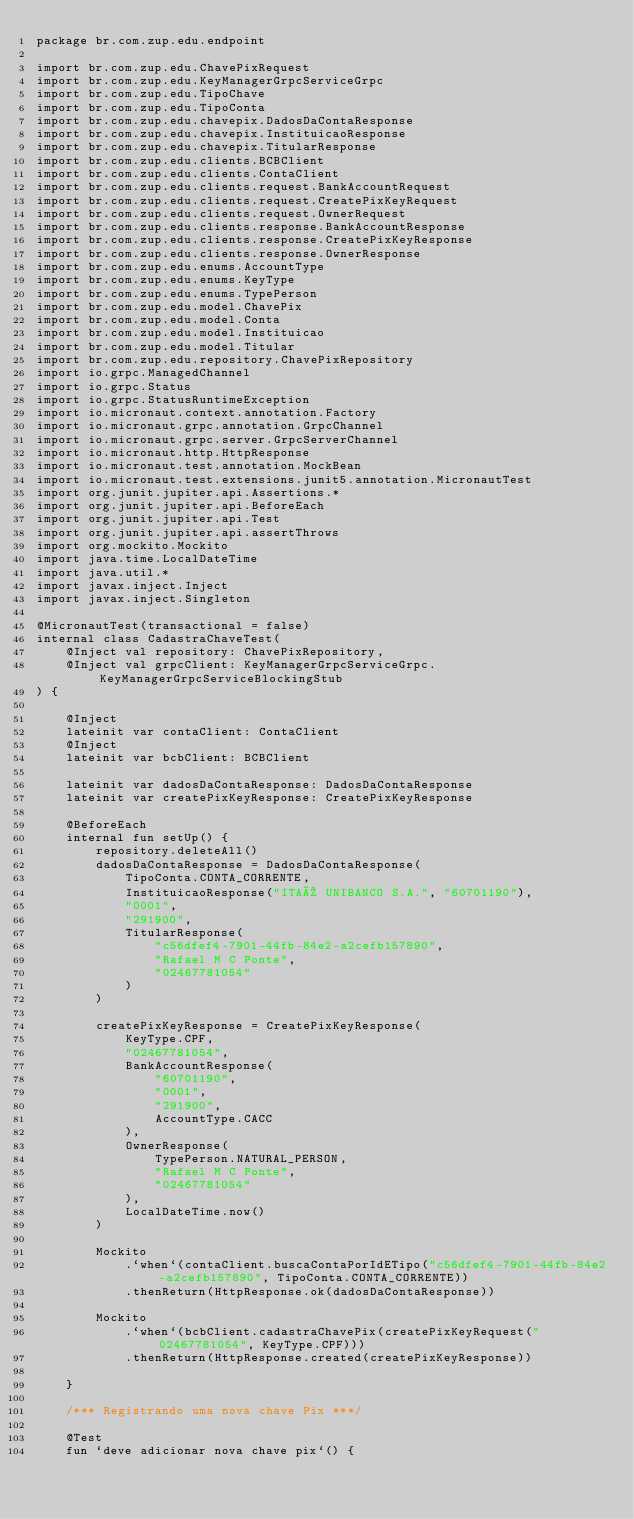Convert code to text. <code><loc_0><loc_0><loc_500><loc_500><_Kotlin_>package br.com.zup.edu.endpoint

import br.com.zup.edu.ChavePixRequest
import br.com.zup.edu.KeyManagerGrpcServiceGrpc
import br.com.zup.edu.TipoChave
import br.com.zup.edu.TipoConta
import br.com.zup.edu.chavepix.DadosDaContaResponse
import br.com.zup.edu.chavepix.InstituicaoResponse
import br.com.zup.edu.chavepix.TitularResponse
import br.com.zup.edu.clients.BCBClient
import br.com.zup.edu.clients.ContaClient
import br.com.zup.edu.clients.request.BankAccountRequest
import br.com.zup.edu.clients.request.CreatePixKeyRequest
import br.com.zup.edu.clients.request.OwnerRequest
import br.com.zup.edu.clients.response.BankAccountResponse
import br.com.zup.edu.clients.response.CreatePixKeyResponse
import br.com.zup.edu.clients.response.OwnerResponse
import br.com.zup.edu.enums.AccountType
import br.com.zup.edu.enums.KeyType
import br.com.zup.edu.enums.TypePerson
import br.com.zup.edu.model.ChavePix
import br.com.zup.edu.model.Conta
import br.com.zup.edu.model.Instituicao
import br.com.zup.edu.model.Titular
import br.com.zup.edu.repository.ChavePixRepository
import io.grpc.ManagedChannel
import io.grpc.Status
import io.grpc.StatusRuntimeException
import io.micronaut.context.annotation.Factory
import io.micronaut.grpc.annotation.GrpcChannel
import io.micronaut.grpc.server.GrpcServerChannel
import io.micronaut.http.HttpResponse
import io.micronaut.test.annotation.MockBean
import io.micronaut.test.extensions.junit5.annotation.MicronautTest
import org.junit.jupiter.api.Assertions.*
import org.junit.jupiter.api.BeforeEach
import org.junit.jupiter.api.Test
import org.junit.jupiter.api.assertThrows
import org.mockito.Mockito
import java.time.LocalDateTime
import java.util.*
import javax.inject.Inject
import javax.inject.Singleton

@MicronautTest(transactional = false)
internal class CadastraChaveTest(
    @Inject val repository: ChavePixRepository,
    @Inject val grpcClient: KeyManagerGrpcServiceGrpc.KeyManagerGrpcServiceBlockingStub
) {

    @Inject
    lateinit var contaClient: ContaClient
    @Inject
    lateinit var bcbClient: BCBClient

    lateinit var dadosDaContaResponse: DadosDaContaResponse
    lateinit var createPixKeyResponse: CreatePixKeyResponse

    @BeforeEach
    internal fun setUp() {
        repository.deleteAll()
        dadosDaContaResponse = DadosDaContaResponse(
            TipoConta.CONTA_CORRENTE,
            InstituicaoResponse("ITAÚ UNIBANCO S.A.", "60701190"),
            "0001",
            "291900",
            TitularResponse(
                "c56dfef4-7901-44fb-84e2-a2cefb157890",
                "Rafael M C Ponte",
                "02467781054"
            )
        )

        createPixKeyResponse = CreatePixKeyResponse(
            KeyType.CPF,
            "02467781054",
            BankAccountResponse(
                "60701190",
                "0001",
                "291900",
                AccountType.CACC
            ),
            OwnerResponse(
                TypePerson.NATURAL_PERSON,
                "Rafael M C Ponte",
                "02467781054"
            ),
            LocalDateTime.now()
        )

        Mockito
            .`when`(contaClient.buscaContaPorIdETipo("c56dfef4-7901-44fb-84e2-a2cefb157890", TipoConta.CONTA_CORRENTE))
            .thenReturn(HttpResponse.ok(dadosDaContaResponse))

        Mockito
            .`when`(bcbClient.cadastraChavePix(createPixKeyRequest("02467781054", KeyType.CPF)))
            .thenReturn(HttpResponse.created(createPixKeyResponse))

    }

    /*** Registrando uma nova chave Pix ***/

    @Test
    fun `deve adicionar nova chave pix`() {
</code> 